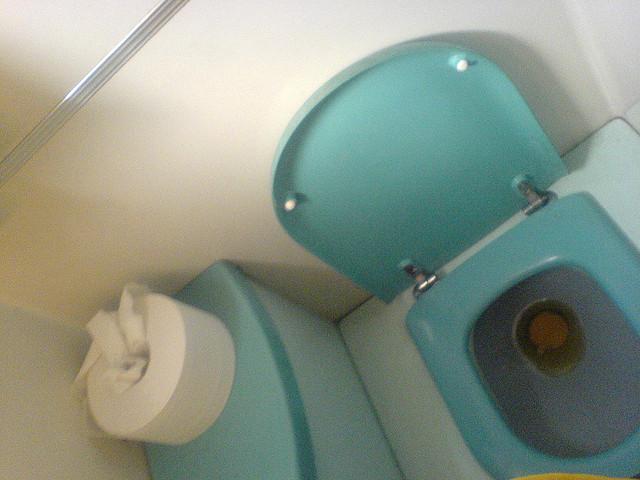What can somebody do while sitting on the toilet?
Short answer required. Use it. What is the large white circular object to the left?
Give a very brief answer. Toilet paper. What room is this?
Write a very short answer. Bathroom. Why is the toilet seat blue?
Give a very brief answer. Painted. 